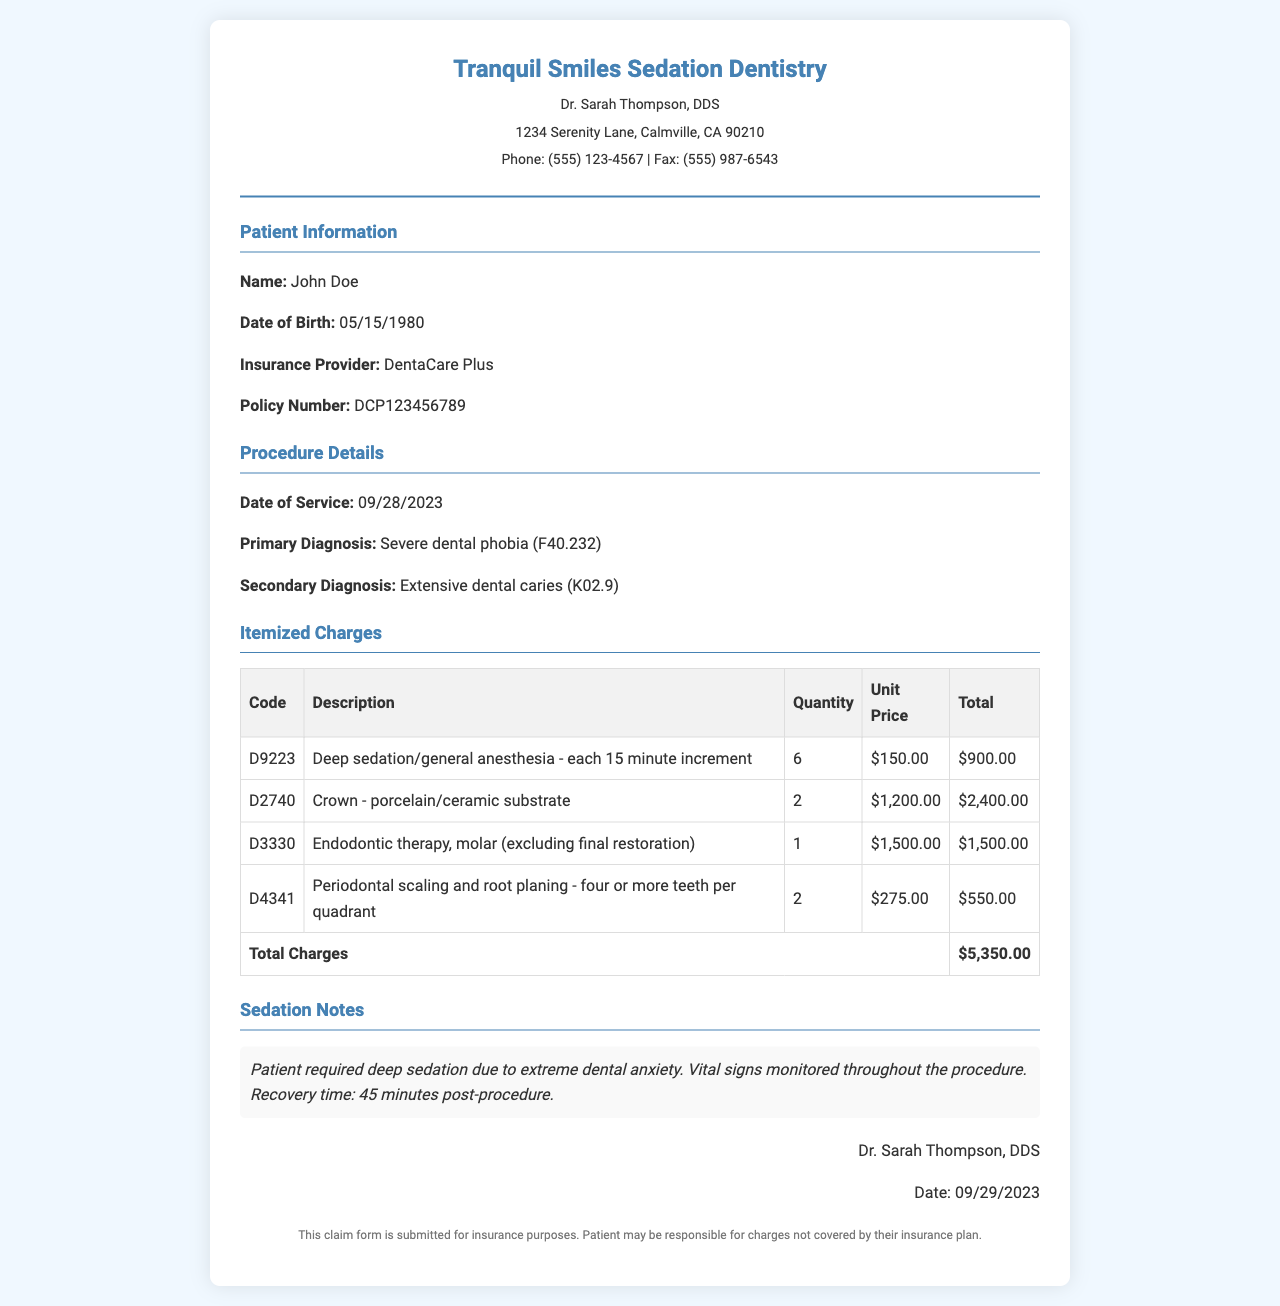what is the patient's name? The patient's name can be found in the Patient Information section.
Answer: John Doe what is the total amount of charges? The total charges are listed under Itemized Charges at the end of the table.
Answer: $5,350.00 what is the primary diagnosis code? The primary diagnosis code is located in the Procedure Details section.
Answer: F40.232 how many units were billed for deep sedation? The quantity for deep sedation is specified in the Itemized Charges table.
Answer: 6 what is the procedure date? The date of service is detailed in the Procedure Details section.
Answer: 09/28/2023 which insurance provider is listed? The insurance provider is specified in the Patient Information section.
Answer: DentaCare Plus what type of procedure was performed to address severe anxiety? This information is detailed in the Sedation Notes section.
Answer: Deep sedation who is the dentist treating the patient? The treating dentist's name is found in the header of the document.
Answer: Dr. Sarah Thompson, DDS what is the policy number for the patient? The policy number is included in the Patient Information section.
Answer: DCP123456789 